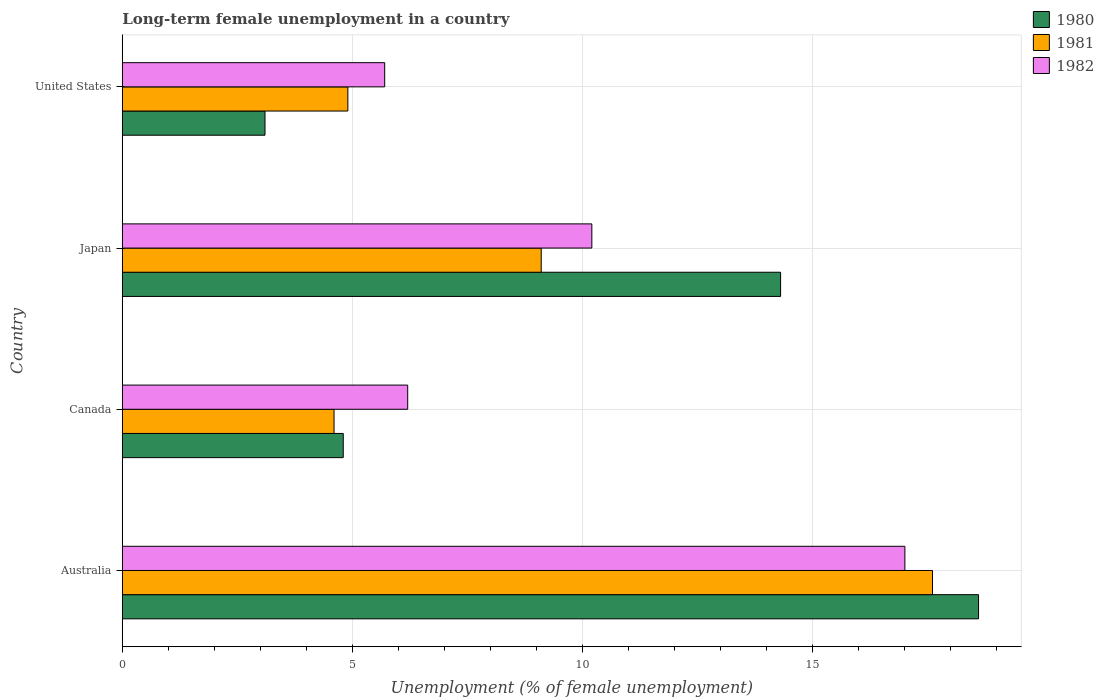Are the number of bars per tick equal to the number of legend labels?
Keep it short and to the point. Yes. Are the number of bars on each tick of the Y-axis equal?
Offer a very short reply. Yes. What is the label of the 1st group of bars from the top?
Keep it short and to the point. United States. What is the percentage of long-term unemployed female population in 1981 in Australia?
Keep it short and to the point. 17.6. Across all countries, what is the maximum percentage of long-term unemployed female population in 1980?
Offer a terse response. 18.6. Across all countries, what is the minimum percentage of long-term unemployed female population in 1981?
Provide a short and direct response. 4.6. In which country was the percentage of long-term unemployed female population in 1981 minimum?
Offer a terse response. Canada. What is the total percentage of long-term unemployed female population in 1980 in the graph?
Offer a terse response. 40.8. What is the difference between the percentage of long-term unemployed female population in 1982 in Australia and that in Japan?
Ensure brevity in your answer.  6.8. What is the difference between the percentage of long-term unemployed female population in 1981 in Canada and the percentage of long-term unemployed female population in 1980 in Australia?
Offer a terse response. -14. What is the average percentage of long-term unemployed female population in 1982 per country?
Keep it short and to the point. 9.77. What is the difference between the percentage of long-term unemployed female population in 1981 and percentage of long-term unemployed female population in 1982 in Japan?
Your answer should be very brief. -1.1. In how many countries, is the percentage of long-term unemployed female population in 1982 greater than 12 %?
Provide a succinct answer. 1. What is the ratio of the percentage of long-term unemployed female population in 1980 in Australia to that in Japan?
Your answer should be compact. 1.3. Is the difference between the percentage of long-term unemployed female population in 1981 in Australia and Japan greater than the difference between the percentage of long-term unemployed female population in 1982 in Australia and Japan?
Ensure brevity in your answer.  Yes. What is the difference between the highest and the second highest percentage of long-term unemployed female population in 1980?
Make the answer very short. 4.3. What is the difference between the highest and the lowest percentage of long-term unemployed female population in 1981?
Your response must be concise. 13. Is it the case that in every country, the sum of the percentage of long-term unemployed female population in 1981 and percentage of long-term unemployed female population in 1980 is greater than the percentage of long-term unemployed female population in 1982?
Give a very brief answer. Yes. Are the values on the major ticks of X-axis written in scientific E-notation?
Your answer should be compact. No. Does the graph contain any zero values?
Offer a very short reply. No. Does the graph contain grids?
Offer a terse response. Yes. Where does the legend appear in the graph?
Your answer should be compact. Top right. What is the title of the graph?
Give a very brief answer. Long-term female unemployment in a country. What is the label or title of the X-axis?
Your answer should be compact. Unemployment (% of female unemployment). What is the label or title of the Y-axis?
Make the answer very short. Country. What is the Unemployment (% of female unemployment) of 1980 in Australia?
Keep it short and to the point. 18.6. What is the Unemployment (% of female unemployment) of 1981 in Australia?
Ensure brevity in your answer.  17.6. What is the Unemployment (% of female unemployment) of 1980 in Canada?
Ensure brevity in your answer.  4.8. What is the Unemployment (% of female unemployment) in 1981 in Canada?
Your answer should be compact. 4.6. What is the Unemployment (% of female unemployment) in 1982 in Canada?
Provide a succinct answer. 6.2. What is the Unemployment (% of female unemployment) in 1980 in Japan?
Your answer should be very brief. 14.3. What is the Unemployment (% of female unemployment) of 1981 in Japan?
Your answer should be very brief. 9.1. What is the Unemployment (% of female unemployment) of 1982 in Japan?
Offer a terse response. 10.2. What is the Unemployment (% of female unemployment) of 1980 in United States?
Your answer should be compact. 3.1. What is the Unemployment (% of female unemployment) of 1981 in United States?
Offer a very short reply. 4.9. What is the Unemployment (% of female unemployment) in 1982 in United States?
Offer a terse response. 5.7. Across all countries, what is the maximum Unemployment (% of female unemployment) of 1980?
Offer a very short reply. 18.6. Across all countries, what is the maximum Unemployment (% of female unemployment) in 1981?
Make the answer very short. 17.6. Across all countries, what is the maximum Unemployment (% of female unemployment) of 1982?
Provide a short and direct response. 17. Across all countries, what is the minimum Unemployment (% of female unemployment) of 1980?
Ensure brevity in your answer.  3.1. Across all countries, what is the minimum Unemployment (% of female unemployment) in 1981?
Your response must be concise. 4.6. Across all countries, what is the minimum Unemployment (% of female unemployment) of 1982?
Provide a short and direct response. 5.7. What is the total Unemployment (% of female unemployment) of 1980 in the graph?
Your answer should be compact. 40.8. What is the total Unemployment (% of female unemployment) of 1981 in the graph?
Your answer should be compact. 36.2. What is the total Unemployment (% of female unemployment) of 1982 in the graph?
Provide a short and direct response. 39.1. What is the difference between the Unemployment (% of female unemployment) in 1980 in Australia and that in Canada?
Offer a terse response. 13.8. What is the difference between the Unemployment (% of female unemployment) in 1982 in Australia and that in Canada?
Give a very brief answer. 10.8. What is the difference between the Unemployment (% of female unemployment) in 1980 in Australia and that in Japan?
Your answer should be very brief. 4.3. What is the difference between the Unemployment (% of female unemployment) in 1982 in Australia and that in Japan?
Offer a terse response. 6.8. What is the difference between the Unemployment (% of female unemployment) in 1980 in Canada and that in Japan?
Keep it short and to the point. -9.5. What is the difference between the Unemployment (% of female unemployment) in 1980 in Canada and that in United States?
Offer a terse response. 1.7. What is the difference between the Unemployment (% of female unemployment) of 1981 in Japan and that in United States?
Keep it short and to the point. 4.2. What is the difference between the Unemployment (% of female unemployment) in 1982 in Japan and that in United States?
Provide a short and direct response. 4.5. What is the difference between the Unemployment (% of female unemployment) in 1980 in Australia and the Unemployment (% of female unemployment) in 1981 in Canada?
Provide a short and direct response. 14. What is the difference between the Unemployment (% of female unemployment) in 1980 in Australia and the Unemployment (% of female unemployment) in 1982 in Canada?
Offer a terse response. 12.4. What is the difference between the Unemployment (% of female unemployment) of 1981 in Australia and the Unemployment (% of female unemployment) of 1982 in Japan?
Provide a short and direct response. 7.4. What is the difference between the Unemployment (% of female unemployment) in 1980 in Canada and the Unemployment (% of female unemployment) in 1981 in Japan?
Offer a terse response. -4.3. What is the difference between the Unemployment (% of female unemployment) in 1981 in Canada and the Unemployment (% of female unemployment) in 1982 in United States?
Your answer should be compact. -1.1. What is the difference between the Unemployment (% of female unemployment) in 1981 in Japan and the Unemployment (% of female unemployment) in 1982 in United States?
Provide a short and direct response. 3.4. What is the average Unemployment (% of female unemployment) in 1980 per country?
Give a very brief answer. 10.2. What is the average Unemployment (% of female unemployment) of 1981 per country?
Give a very brief answer. 9.05. What is the average Unemployment (% of female unemployment) in 1982 per country?
Offer a terse response. 9.78. What is the difference between the Unemployment (% of female unemployment) of 1980 and Unemployment (% of female unemployment) of 1981 in Australia?
Your answer should be very brief. 1. What is the difference between the Unemployment (% of female unemployment) in 1980 and Unemployment (% of female unemployment) in 1982 in Australia?
Make the answer very short. 1.6. What is the difference between the Unemployment (% of female unemployment) of 1980 and Unemployment (% of female unemployment) of 1981 in Canada?
Your answer should be very brief. 0.2. What is the difference between the Unemployment (% of female unemployment) of 1980 and Unemployment (% of female unemployment) of 1982 in Canada?
Provide a short and direct response. -1.4. What is the difference between the Unemployment (% of female unemployment) of 1980 and Unemployment (% of female unemployment) of 1981 in United States?
Your response must be concise. -1.8. What is the difference between the Unemployment (% of female unemployment) of 1981 and Unemployment (% of female unemployment) of 1982 in United States?
Provide a succinct answer. -0.8. What is the ratio of the Unemployment (% of female unemployment) in 1980 in Australia to that in Canada?
Keep it short and to the point. 3.88. What is the ratio of the Unemployment (% of female unemployment) in 1981 in Australia to that in Canada?
Keep it short and to the point. 3.83. What is the ratio of the Unemployment (% of female unemployment) in 1982 in Australia to that in Canada?
Make the answer very short. 2.74. What is the ratio of the Unemployment (% of female unemployment) of 1980 in Australia to that in Japan?
Your answer should be compact. 1.3. What is the ratio of the Unemployment (% of female unemployment) of 1981 in Australia to that in Japan?
Your answer should be compact. 1.93. What is the ratio of the Unemployment (% of female unemployment) in 1982 in Australia to that in Japan?
Offer a terse response. 1.67. What is the ratio of the Unemployment (% of female unemployment) of 1981 in Australia to that in United States?
Offer a very short reply. 3.59. What is the ratio of the Unemployment (% of female unemployment) of 1982 in Australia to that in United States?
Your answer should be compact. 2.98. What is the ratio of the Unemployment (% of female unemployment) in 1980 in Canada to that in Japan?
Offer a terse response. 0.34. What is the ratio of the Unemployment (% of female unemployment) of 1981 in Canada to that in Japan?
Your answer should be very brief. 0.51. What is the ratio of the Unemployment (% of female unemployment) in 1982 in Canada to that in Japan?
Your answer should be very brief. 0.61. What is the ratio of the Unemployment (% of female unemployment) of 1980 in Canada to that in United States?
Keep it short and to the point. 1.55. What is the ratio of the Unemployment (% of female unemployment) in 1981 in Canada to that in United States?
Your answer should be very brief. 0.94. What is the ratio of the Unemployment (% of female unemployment) in 1982 in Canada to that in United States?
Offer a very short reply. 1.09. What is the ratio of the Unemployment (% of female unemployment) of 1980 in Japan to that in United States?
Provide a succinct answer. 4.61. What is the ratio of the Unemployment (% of female unemployment) of 1981 in Japan to that in United States?
Offer a terse response. 1.86. What is the ratio of the Unemployment (% of female unemployment) of 1982 in Japan to that in United States?
Your answer should be compact. 1.79. What is the difference between the highest and the second highest Unemployment (% of female unemployment) of 1980?
Your answer should be compact. 4.3. What is the difference between the highest and the second highest Unemployment (% of female unemployment) in 1982?
Make the answer very short. 6.8. What is the difference between the highest and the lowest Unemployment (% of female unemployment) in 1980?
Your response must be concise. 15.5. What is the difference between the highest and the lowest Unemployment (% of female unemployment) of 1981?
Provide a short and direct response. 13. 